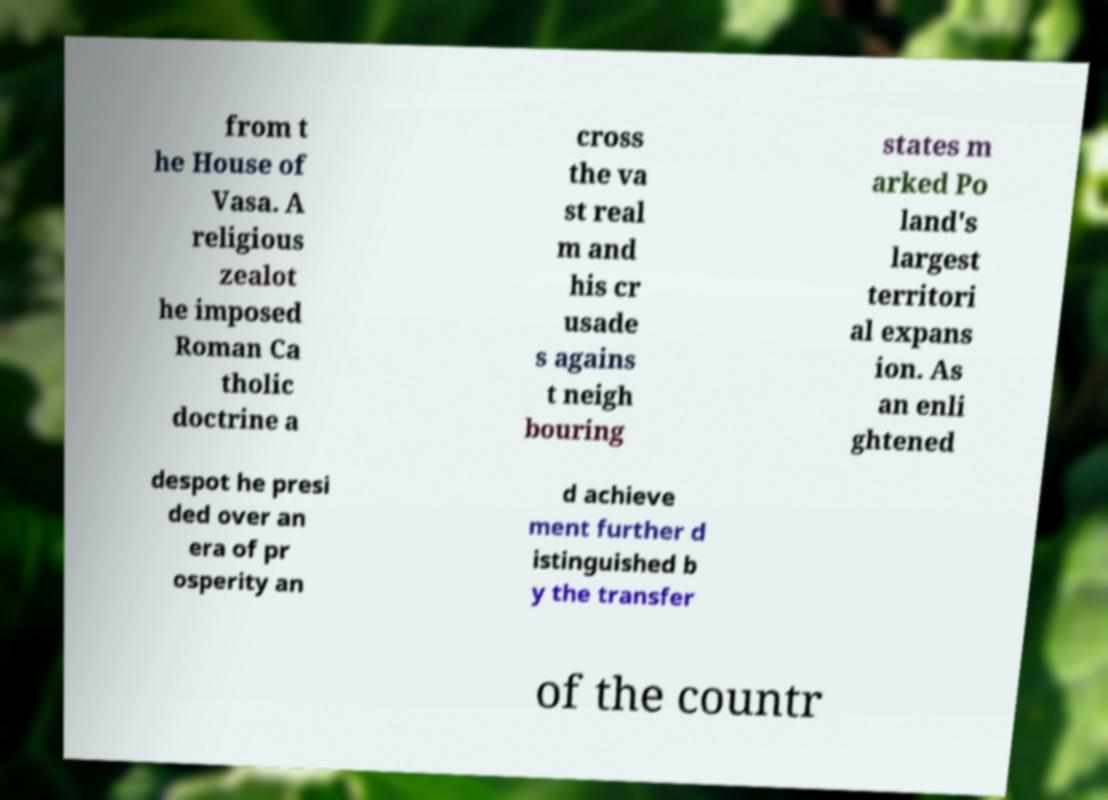Could you extract and type out the text from this image? from t he House of Vasa. A religious zealot he imposed Roman Ca tholic doctrine a cross the va st real m and his cr usade s agains t neigh bouring states m arked Po land's largest territori al expans ion. As an enli ghtened despot he presi ded over an era of pr osperity an d achieve ment further d istinguished b y the transfer of the countr 